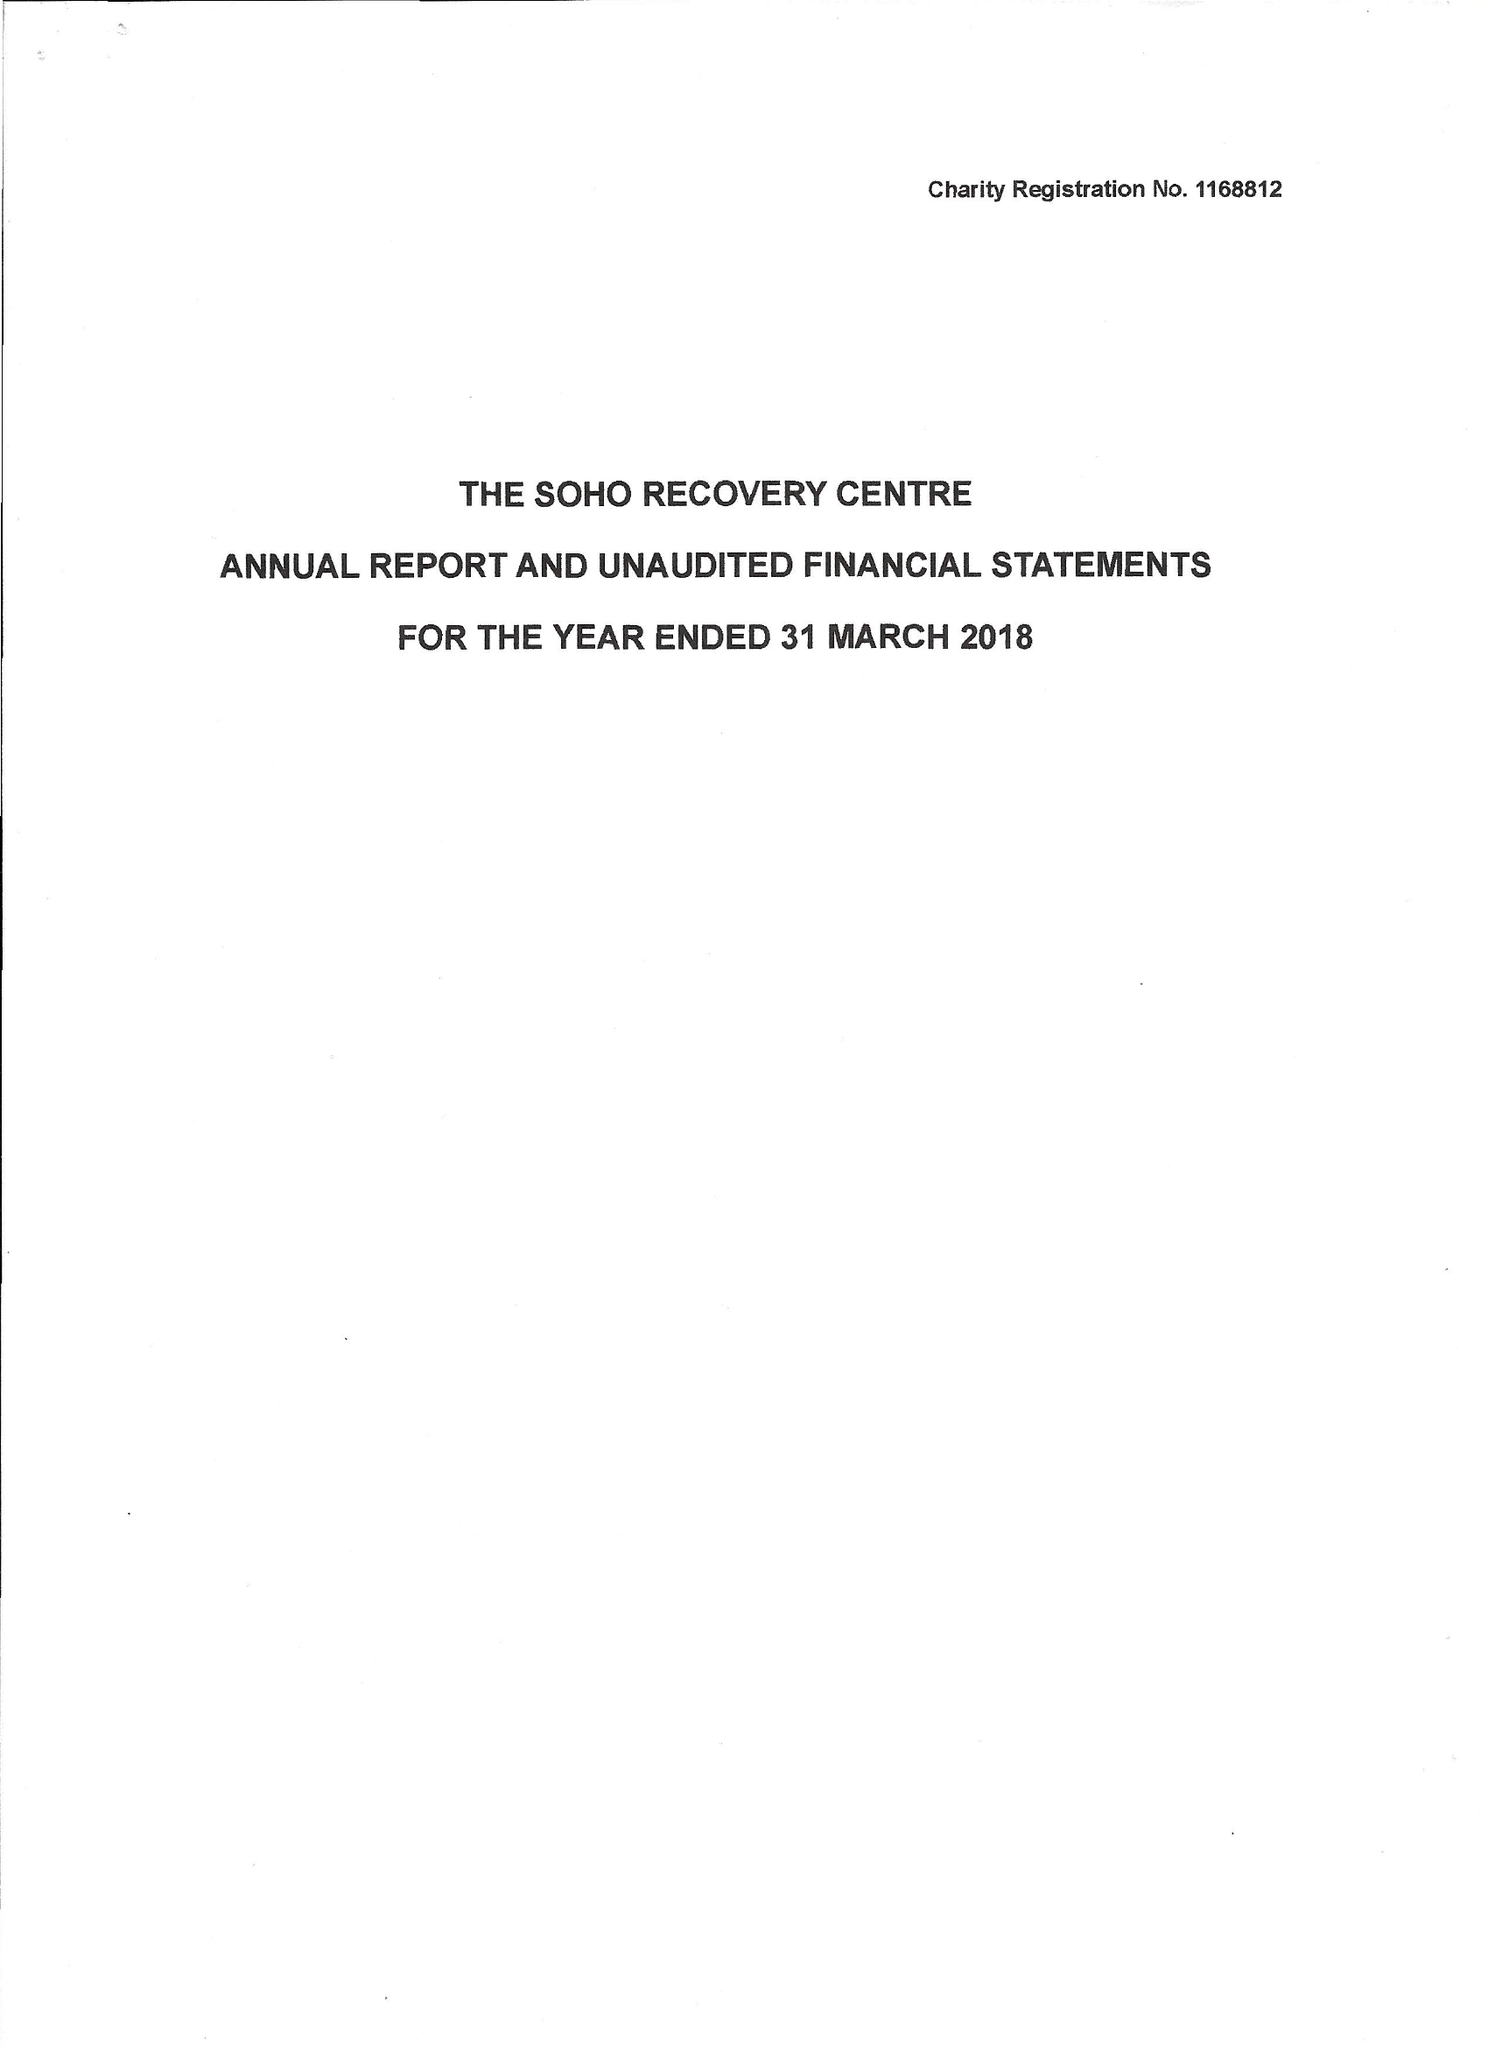What is the value for the charity_number?
Answer the question using a single word or phrase. 1168812 